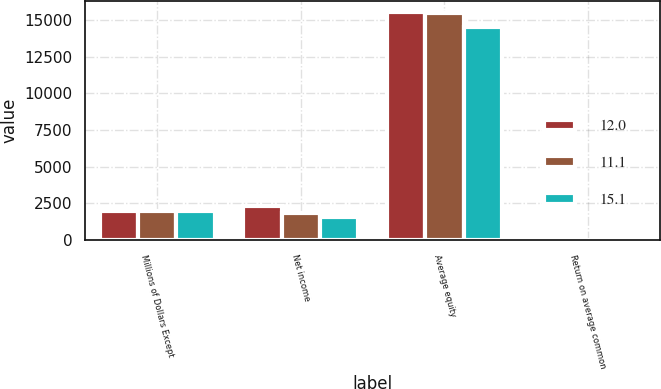Convert chart to OTSL. <chart><loc_0><loc_0><loc_500><loc_500><stacked_bar_chart><ecel><fcel>Millions of Dollars Except<fcel>Net income<fcel>Average equity<fcel>Return on average common<nl><fcel>12<fcel>2008<fcel>2338<fcel>15516<fcel>15.1<nl><fcel>11.1<fcel>2007<fcel>1855<fcel>15448<fcel>12<nl><fcel>15.1<fcel>2006<fcel>1606<fcel>14510<fcel>11.1<nl></chart> 